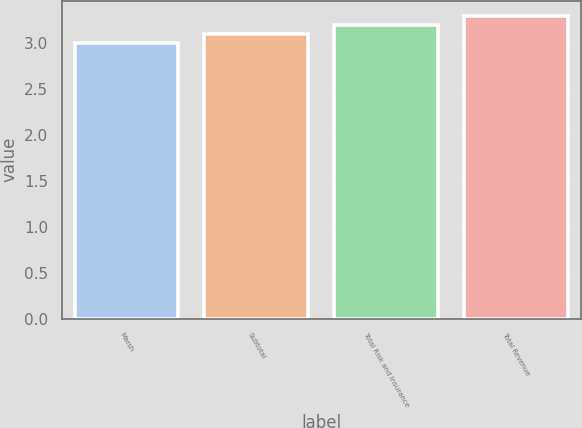Convert chart to OTSL. <chart><loc_0><loc_0><loc_500><loc_500><bar_chart><fcel>Marsh<fcel>Subtotal<fcel>Total Risk and Insurance<fcel>Total Revenue<nl><fcel>3<fcel>3.1<fcel>3.2<fcel>3.3<nl></chart> 